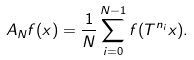Convert formula to latex. <formula><loc_0><loc_0><loc_500><loc_500>A _ { N } f ( x ) = \frac { 1 } { N } \sum _ { i = 0 } ^ { N - 1 } f ( T ^ { n _ { i } } x ) .</formula> 